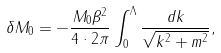<formula> <loc_0><loc_0><loc_500><loc_500>\delta M _ { 0 } = - \frac { M _ { 0 } \beta ^ { 2 } } { 4 \cdot 2 \pi } \int _ { 0 } ^ { \Lambda } \frac { d k } { \sqrt { k ^ { 2 } + m ^ { 2 } } } ,</formula> 